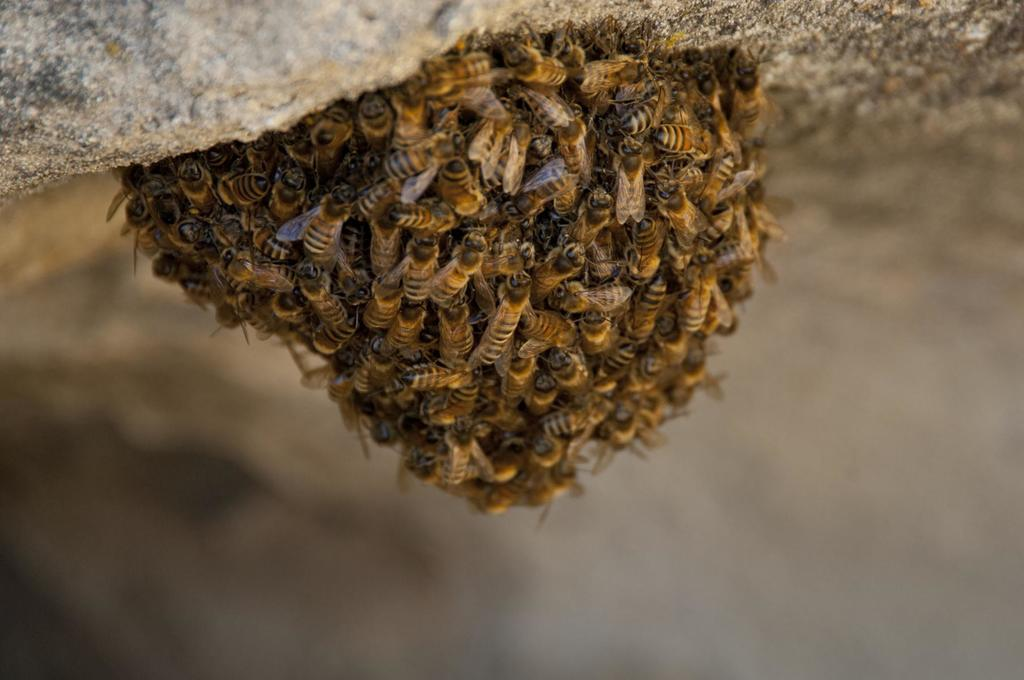What is the main object in the image? There is a stone in the image. What is on top of the stone? There is a honeycomb on the stone. What insects can be seen on the honeycomb? Honey bees are present on the honeycomb. What type of trail can be seen in the image? There is no trail present in the image; it features a stone with a honeycomb and honey bees. How does the voice of the honey bees sound in the image? The image is static, so there is no sound or voice of the honey bees present. 